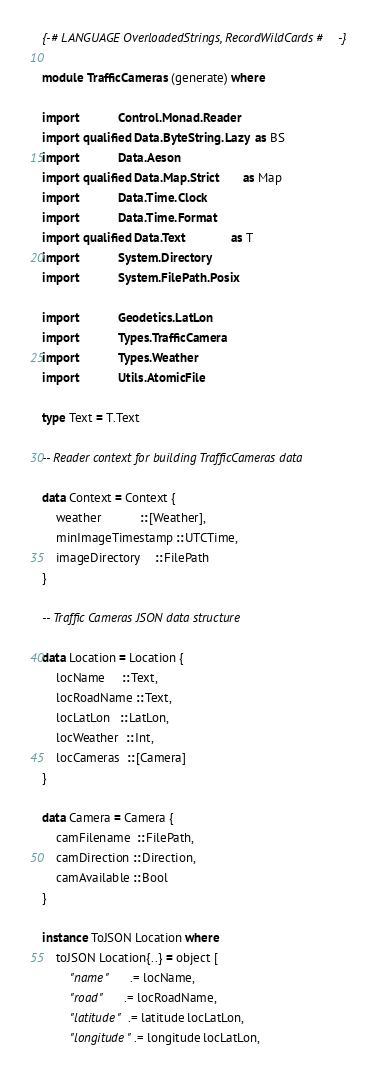Convert code to text. <code><loc_0><loc_0><loc_500><loc_500><_Haskell_>{-# LANGUAGE OverloadedStrings, RecordWildCards #-}

module TrafficCameras (generate) where

import           Control.Monad.Reader
import qualified Data.ByteString.Lazy  as BS
import           Data.Aeson
import qualified Data.Map.Strict       as Map
import           Data.Time.Clock
import           Data.Time.Format
import qualified Data.Text             as T
import           System.Directory
import           System.FilePath.Posix

import           Geodetics.LatLon
import           Types.TrafficCamera
import           Types.Weather
import           Utils.AtomicFile

type Text = T.Text

-- Reader context for building TrafficCameras data

data Context = Context {
    weather           :: [Weather],
    minImageTimestamp :: UTCTime,
    imageDirectory    :: FilePath
}

-- Traffic Cameras JSON data structure

data Location = Location {
    locName     :: Text,
    locRoadName :: Text,
    locLatLon   :: LatLon,
    locWeather  :: Int,
    locCameras  :: [Camera]
}

data Camera = Camera {
    camFilename  :: FilePath,
    camDirection :: Direction,
    camAvailable :: Bool
}

instance ToJSON Location where
    toJSON Location{..} = object [
        "name"      .= locName,
        "road"      .= locRoadName,
        "latitude"  .= latitude locLatLon,
        "longitude" .= longitude locLatLon,</code> 